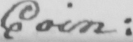Can you tell me what this handwritten text says? Coin : 